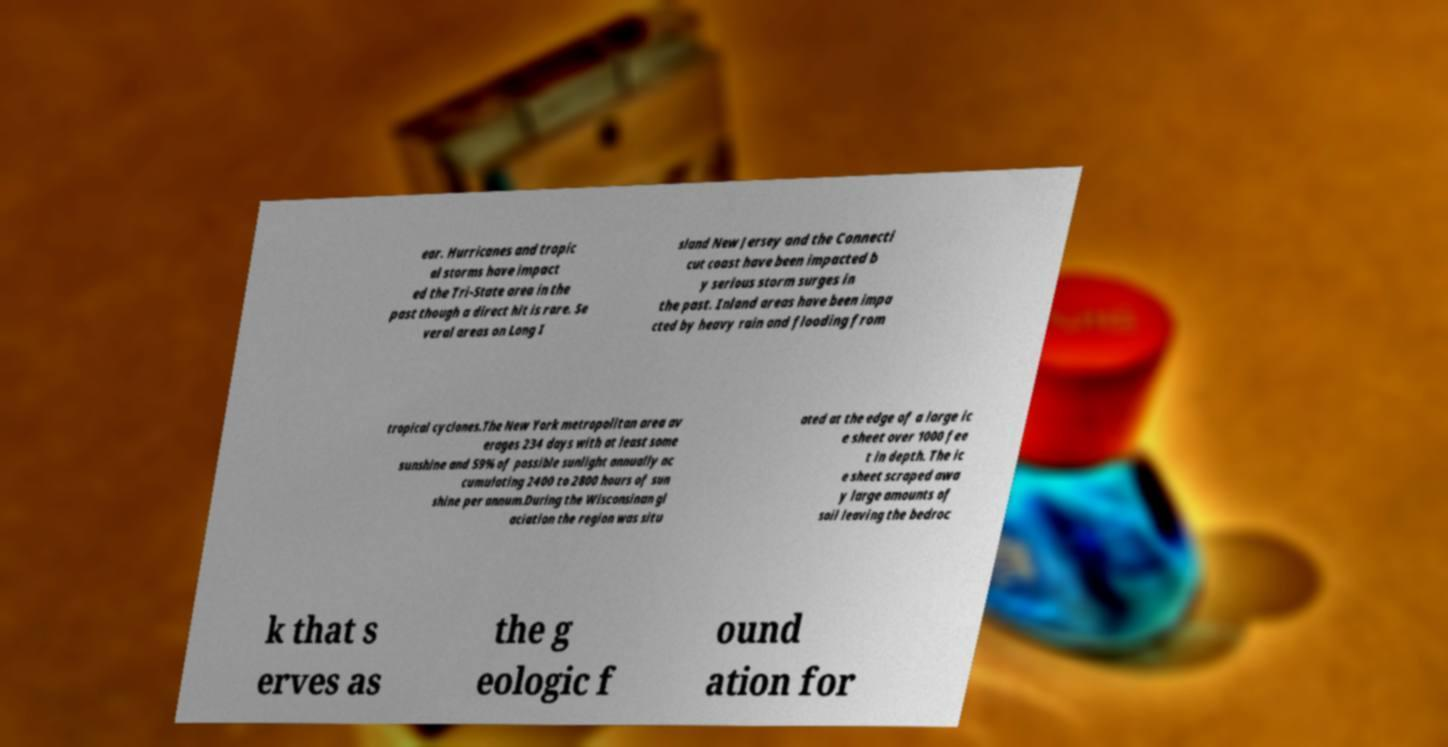Could you extract and type out the text from this image? ear. Hurricanes and tropic al storms have impact ed the Tri-State area in the past though a direct hit is rare. Se veral areas on Long I sland New Jersey and the Connecti cut coast have been impacted b y serious storm surges in the past. Inland areas have been impa cted by heavy rain and flooding from tropical cyclones.The New York metropolitan area av erages 234 days with at least some sunshine and 59% of possible sunlight annually ac cumulating 2400 to 2800 hours of sun shine per annum.During the Wisconsinan gl aciation the region was situ ated at the edge of a large ic e sheet over 1000 fee t in depth. The ic e sheet scraped awa y large amounts of soil leaving the bedroc k that s erves as the g eologic f ound ation for 